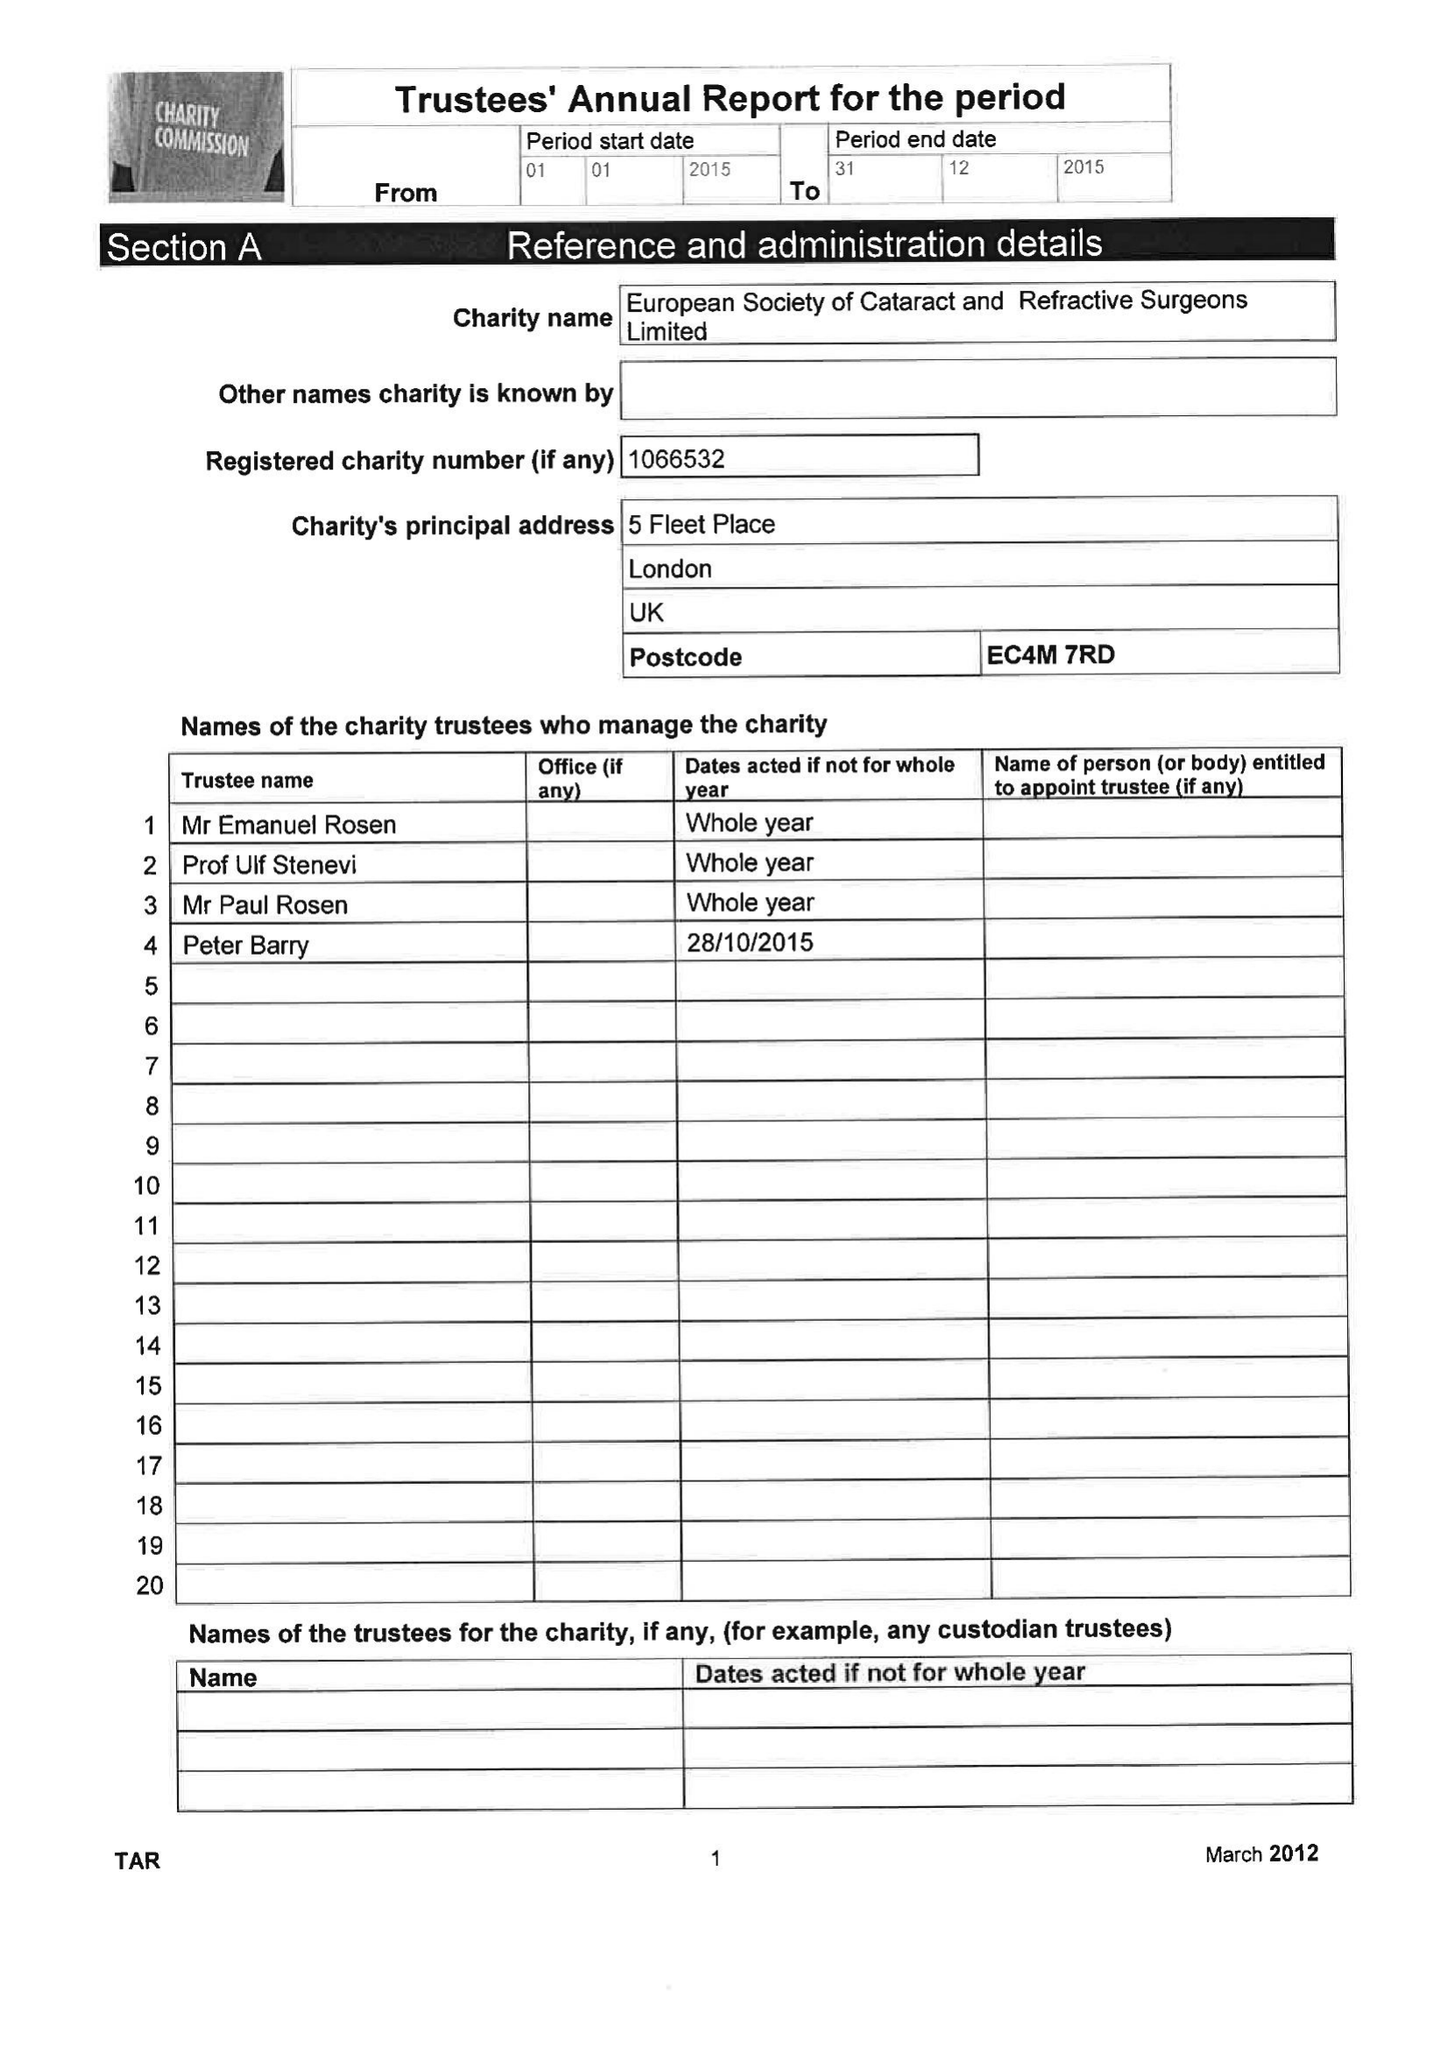What is the value for the address__street_line?
Answer the question using a single word or phrase. 5 FLEET PLACE 